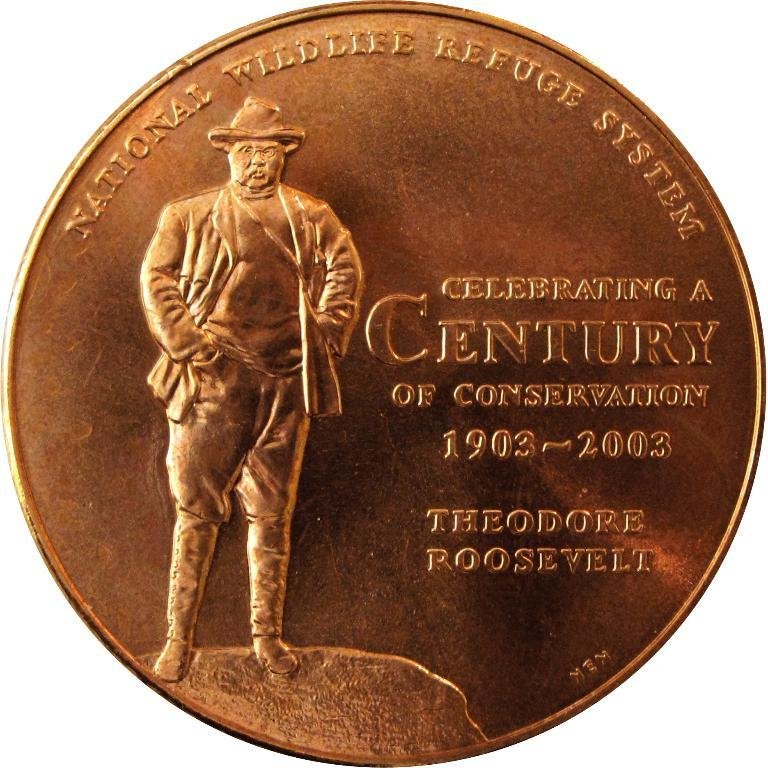Provide a one-sentence caption for the provided image. A special edition coin made for Theodore Roosevelt showing the President standing on a hill. 